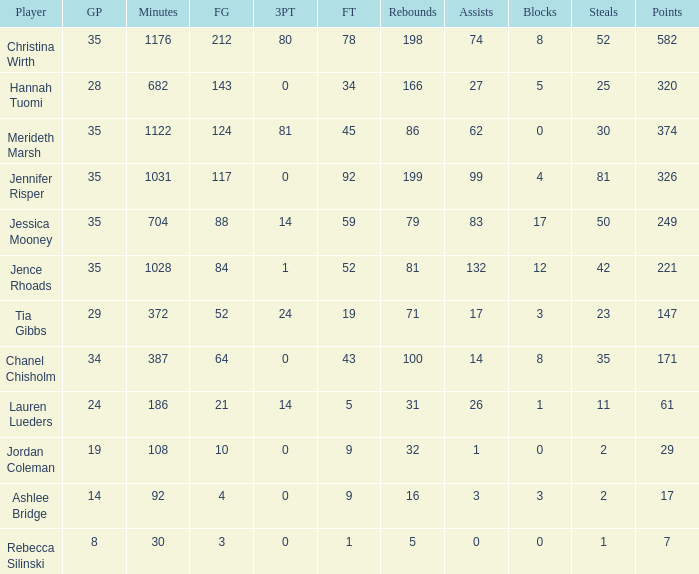What is the lowest number of games played by the player with 50 steals? 35.0. Give me the full table as a dictionary. {'header': ['Player', 'GP', 'Minutes', 'FG', '3PT', 'FT', 'Rebounds', 'Assists', 'Blocks', 'Steals', 'Points'], 'rows': [['Christina Wirth', '35', '1176', '212', '80', '78', '198', '74', '8', '52', '582'], ['Hannah Tuomi', '28', '682', '143', '0', '34', '166', '27', '5', '25', '320'], ['Merideth Marsh', '35', '1122', '124', '81', '45', '86', '62', '0', '30', '374'], ['Jennifer Risper', '35', '1031', '117', '0', '92', '199', '99', '4', '81', '326'], ['Jessica Mooney', '35', '704', '88', '14', '59', '79', '83', '17', '50', '249'], ['Jence Rhoads', '35', '1028', '84', '1', '52', '81', '132', '12', '42', '221'], ['Tia Gibbs', '29', '372', '52', '24', '19', '71', '17', '3', '23', '147'], ['Chanel Chisholm', '34', '387', '64', '0', '43', '100', '14', '8', '35', '171'], ['Lauren Lueders', '24', '186', '21', '14', '5', '31', '26', '1', '11', '61'], ['Jordan Coleman', '19', '108', '10', '0', '9', '32', '1', '0', '2', '29'], ['Ashlee Bridge', '14', '92', '4', '0', '9', '16', '3', '3', '2', '17'], ['Rebecca Silinski', '8', '30', '3', '0', '1', '5', '0', '0', '1', '7']]} 